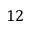<formula> <loc_0><loc_0><loc_500><loc_500>1 2</formula> 